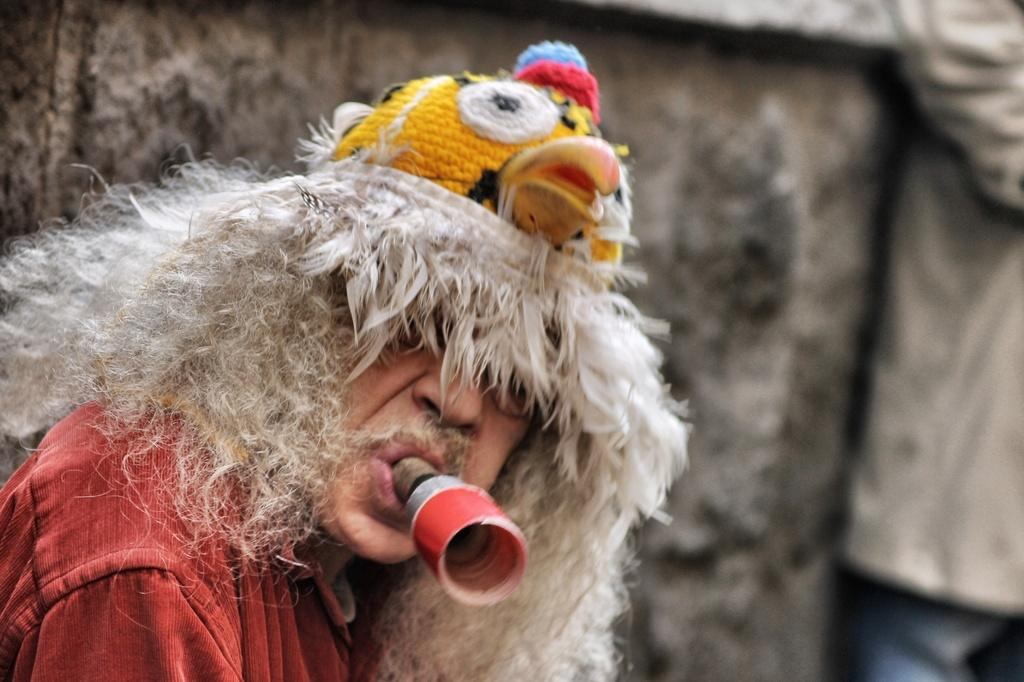Who is present in the image? There is a man in the image. What is the man doing in the image? The man has a whistle in his mouth. What can be seen in the background of the image? There is a wall in the background of the image. What color is the man's toe in the image? There is no mention of the man's toe in the image, so we cannot determine its color. 